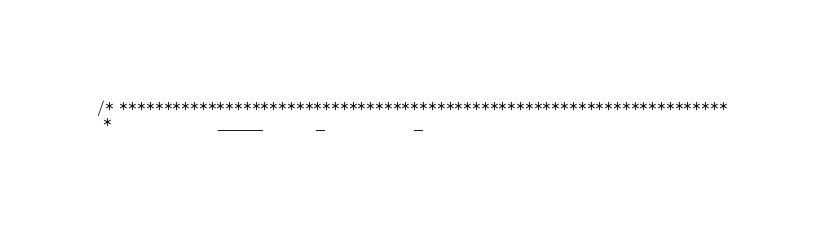<code> <loc_0><loc_0><loc_500><loc_500><_C_>/* *********************************************************************
 *                  _____         _               _</code> 